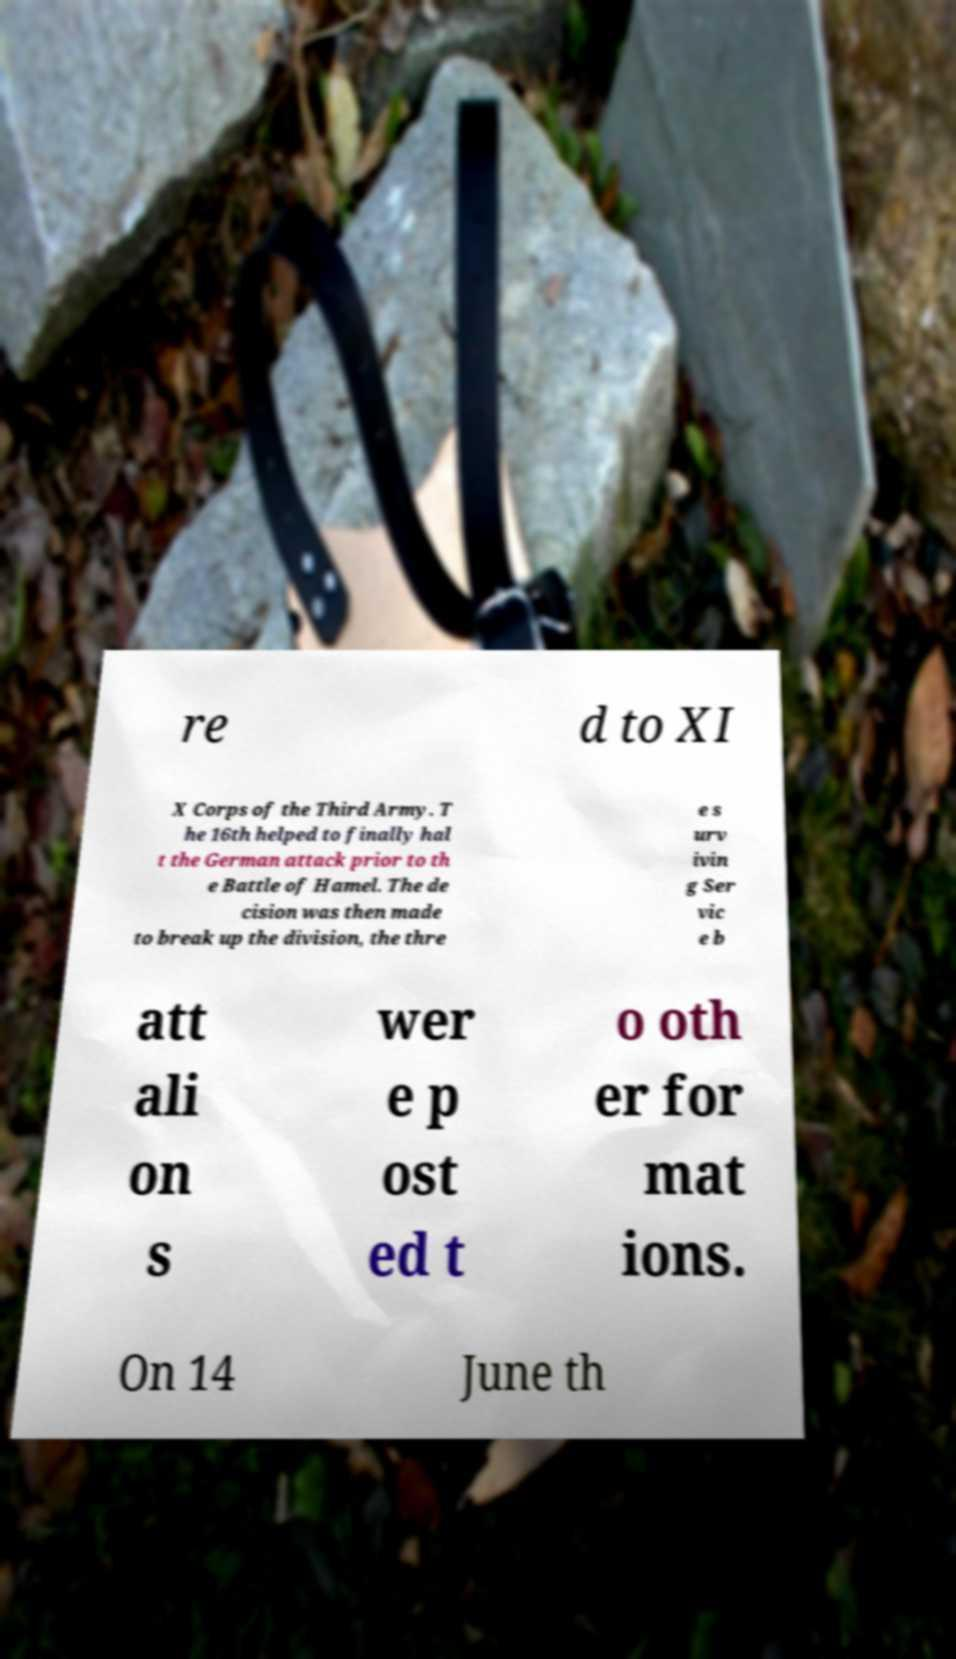For documentation purposes, I need the text within this image transcribed. Could you provide that? re d to XI X Corps of the Third Army. T he 16th helped to finally hal t the German attack prior to th e Battle of Hamel. The de cision was then made to break up the division, the thre e s urv ivin g Ser vic e b att ali on s wer e p ost ed t o oth er for mat ions. On 14 June th 